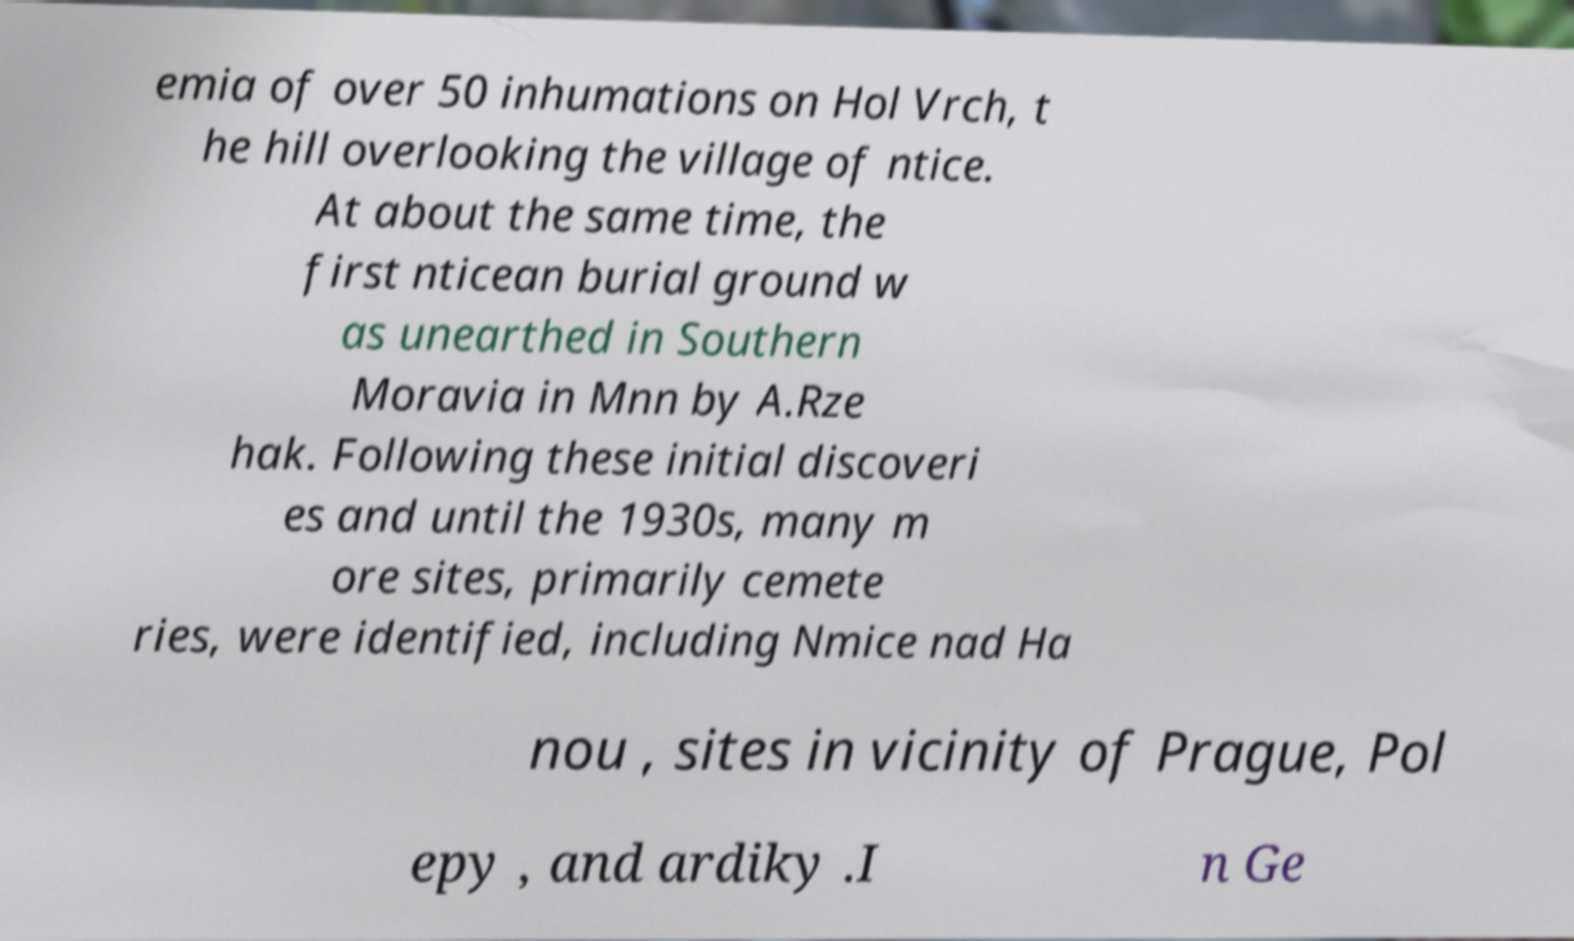Could you assist in decoding the text presented in this image and type it out clearly? emia of over 50 inhumations on Hol Vrch, t he hill overlooking the village of ntice. At about the same time, the first nticean burial ground w as unearthed in Southern Moravia in Mnn by A.Rze hak. Following these initial discoveri es and until the 1930s, many m ore sites, primarily cemete ries, were identified, including Nmice nad Ha nou , sites in vicinity of Prague, Pol epy , and ardiky .I n Ge 